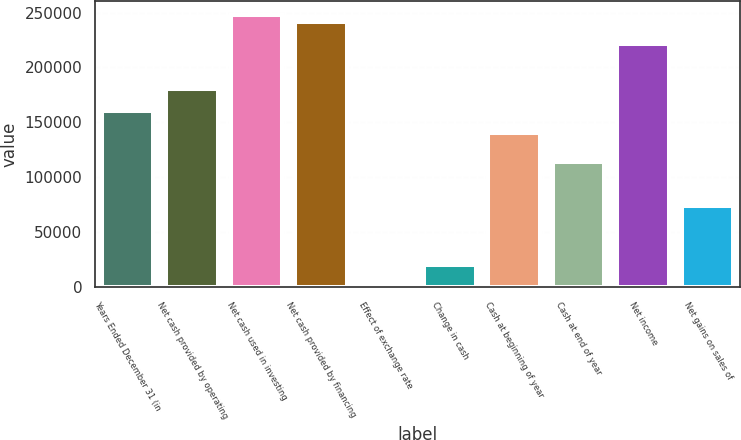Convert chart. <chart><loc_0><loc_0><loc_500><loc_500><bar_chart><fcel>Years Ended December 31 (in<fcel>Net cash provided by operating<fcel>Net cash used in investing<fcel>Net cash provided by financing<fcel>Effect of exchange rate<fcel>Change in cash<fcel>Cash at beginning of year<fcel>Cash at end of year<fcel>Net income<fcel>Net gains on sales of<nl><fcel>160736<fcel>180814<fcel>247740<fcel>241048<fcel>114<fcel>20191.8<fcel>140659<fcel>113888<fcel>220970<fcel>73732.6<nl></chart> 